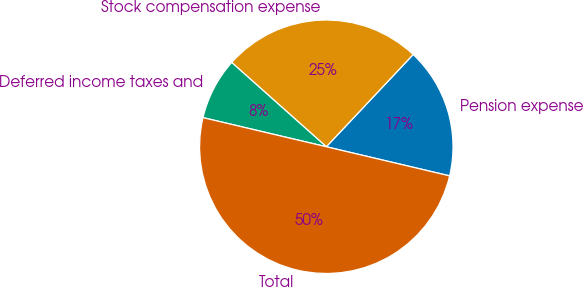Convert chart. <chart><loc_0><loc_0><loc_500><loc_500><pie_chart><fcel>Pension expense<fcel>Stock compensation expense<fcel>Deferred income taxes and<fcel>Total<nl><fcel>16.67%<fcel>25.44%<fcel>7.89%<fcel>50.0%<nl></chart> 